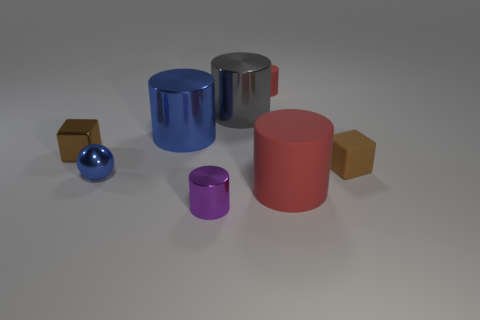Add 1 big blue rubber blocks. How many objects exist? 9 Subtract all metallic cylinders. How many cylinders are left? 2 Subtract 0 cyan spheres. How many objects are left? 8 Subtract all balls. How many objects are left? 7 Subtract 2 blocks. How many blocks are left? 0 Subtract all purple cubes. Subtract all green cylinders. How many cubes are left? 2 Subtract all purple cylinders. How many yellow cubes are left? 0 Subtract all metallic things. Subtract all tiny red cylinders. How many objects are left? 2 Add 5 small brown rubber things. How many small brown rubber things are left? 6 Add 6 small red matte cylinders. How many small red matte cylinders exist? 7 